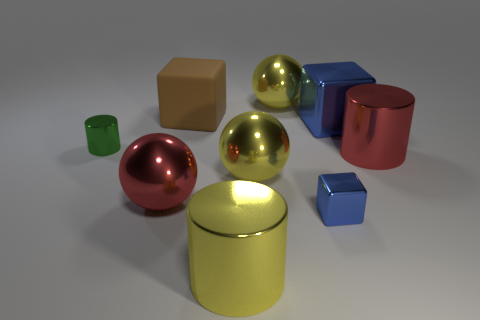Is there any other thing that is made of the same material as the brown block?
Provide a short and direct response. No. Are there fewer blue things that are on the left side of the big yellow metal cylinder than blue cubes on the right side of the tiny blue metal block?
Provide a short and direct response. Yes. The tiny metallic cube is what color?
Provide a short and direct response. Blue. Are there any big shiny blocks that have the same color as the tiny shiny cube?
Offer a terse response. Yes. There is a large red metal thing left of the large yellow ball that is on the left side of the large yellow sphere behind the green shiny cylinder; what is its shape?
Your answer should be very brief. Sphere. What material is the red cylinder that is in front of the large blue thing?
Keep it short and to the point. Metal. How big is the cylinder in front of the small object on the right side of the yellow metal sphere behind the small green cylinder?
Provide a short and direct response. Large. There is a green shiny cylinder; is its size the same as the sphere behind the red cylinder?
Offer a terse response. No. What color is the ball that is behind the large blue object?
Give a very brief answer. Yellow. There is a big metallic thing that is the same color as the tiny block; what shape is it?
Your answer should be very brief. Cube. 